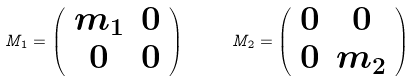Convert formula to latex. <formula><loc_0><loc_0><loc_500><loc_500>M _ { 1 } = \left ( \begin{array} { c c } { { m _ { 1 } } } & { 0 } \\ { 0 } & { 0 } \end{array} \right ) \quad \ M _ { 2 } = \left ( \begin{array} { c c } { 0 } & { 0 } \\ { 0 } & { { m _ { 2 } } } \end{array} \right )</formula> 